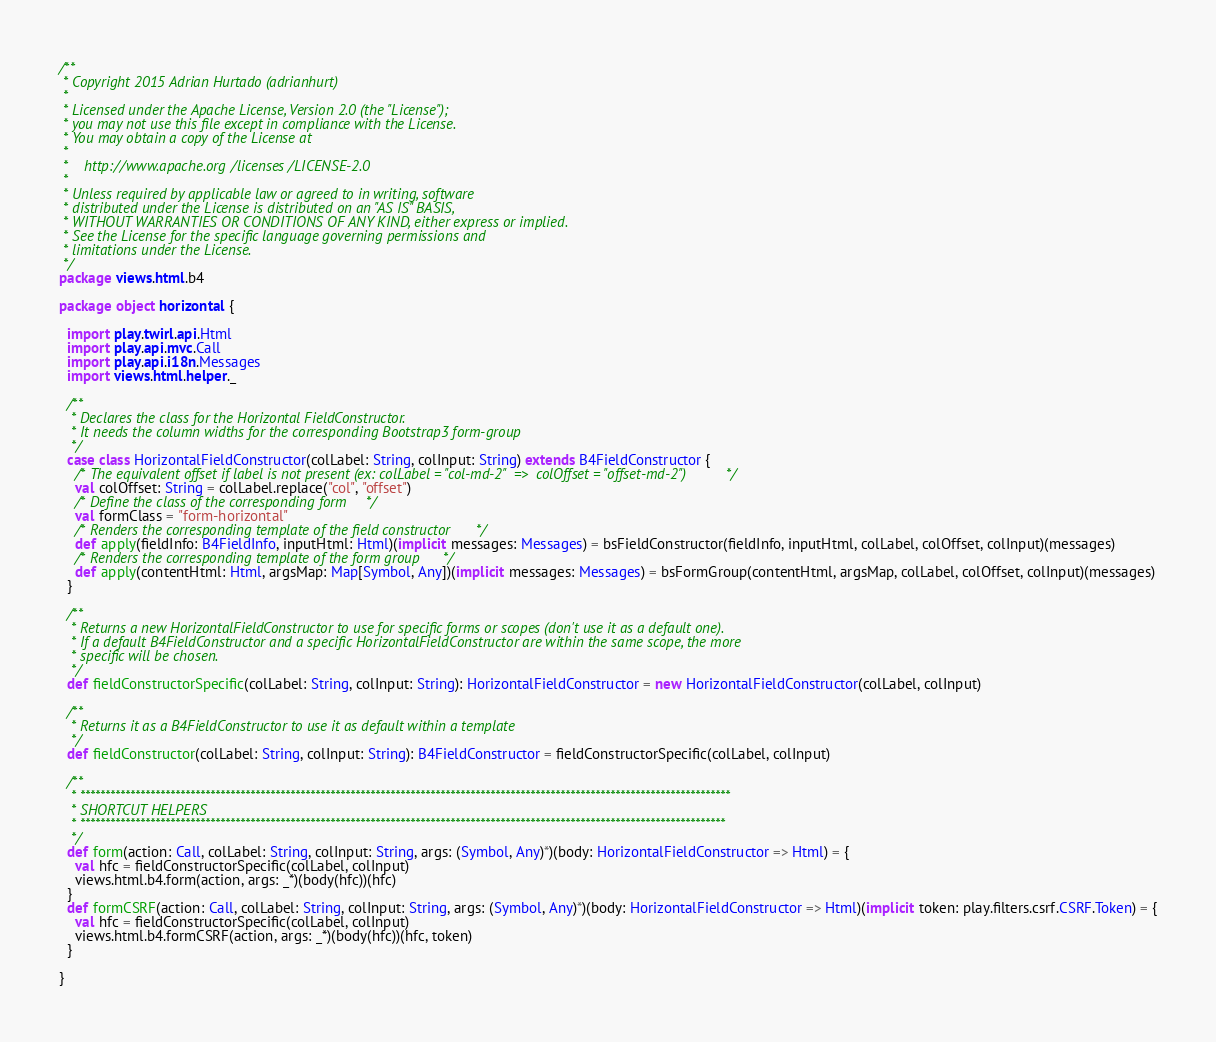<code> <loc_0><loc_0><loc_500><loc_500><_Scala_>/**
 * Copyright 2015 Adrian Hurtado (adrianhurt)
 *
 * Licensed under the Apache License, Version 2.0 (the "License");
 * you may not use this file except in compliance with the License.
 * You may obtain a copy of the License at
 *
 *    http://www.apache.org/licenses/LICENSE-2.0
 *
 * Unless required by applicable law or agreed to in writing, software
 * distributed under the License is distributed on an "AS IS" BASIS,
 * WITHOUT WARRANTIES OR CONDITIONS OF ANY KIND, either express or implied.
 * See the License for the specific language governing permissions and
 * limitations under the License.
 */
package views.html.b4

package object horizontal {

  import play.twirl.api.Html
  import play.api.mvc.Call
  import play.api.i18n.Messages
  import views.html.helper._

  /**
   * Declares the class for the Horizontal FieldConstructor.
   * It needs the column widths for the corresponding Bootstrap3 form-group
   */
  case class HorizontalFieldConstructor(colLabel: String, colInput: String) extends B4FieldConstructor {
    /* The equivalent offset if label is not present (ex: colLabel = "col-md-2"  =>  colOffset = "offset-md-2") */
    val colOffset: String = colLabel.replace("col", "offset")
    /* Define the class of the corresponding form */
    val formClass = "form-horizontal"
    /* Renders the corresponding template of the field constructor */
    def apply(fieldInfo: B4FieldInfo, inputHtml: Html)(implicit messages: Messages) = bsFieldConstructor(fieldInfo, inputHtml, colLabel, colOffset, colInput)(messages)
    /* Renders the corresponding template of the form group */
    def apply(contentHtml: Html, argsMap: Map[Symbol, Any])(implicit messages: Messages) = bsFormGroup(contentHtml, argsMap, colLabel, colOffset, colInput)(messages)
  }

  /**
   * Returns a new HorizontalFieldConstructor to use for specific forms or scopes (don't use it as a default one).
   * If a default B4FieldConstructor and a specific HorizontalFieldConstructor are within the same scope, the more
   * specific will be chosen.
   */
  def fieldConstructorSpecific(colLabel: String, colInput: String): HorizontalFieldConstructor = new HorizontalFieldConstructor(colLabel, colInput)

  /**
   * Returns it as a B4FieldConstructor to use it as default within a template
   */
  def fieldConstructor(colLabel: String, colInput: String): B4FieldConstructor = fieldConstructorSpecific(colLabel, colInput)

  /**
   * **********************************************************************************************************************************
   * SHORTCUT HELPERS
   * *********************************************************************************************************************************
   */
  def form(action: Call, colLabel: String, colInput: String, args: (Symbol, Any)*)(body: HorizontalFieldConstructor => Html) = {
    val hfc = fieldConstructorSpecific(colLabel, colInput)
    views.html.b4.form(action, args: _*)(body(hfc))(hfc)
  }
  def formCSRF(action: Call, colLabel: String, colInput: String, args: (Symbol, Any)*)(body: HorizontalFieldConstructor => Html)(implicit token: play.filters.csrf.CSRF.Token) = {
    val hfc = fieldConstructorSpecific(colLabel, colInput)
    views.html.b4.formCSRF(action, args: _*)(body(hfc))(hfc, token)
  }

}</code> 